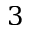<formula> <loc_0><loc_0><loc_500><loc_500>3</formula> 